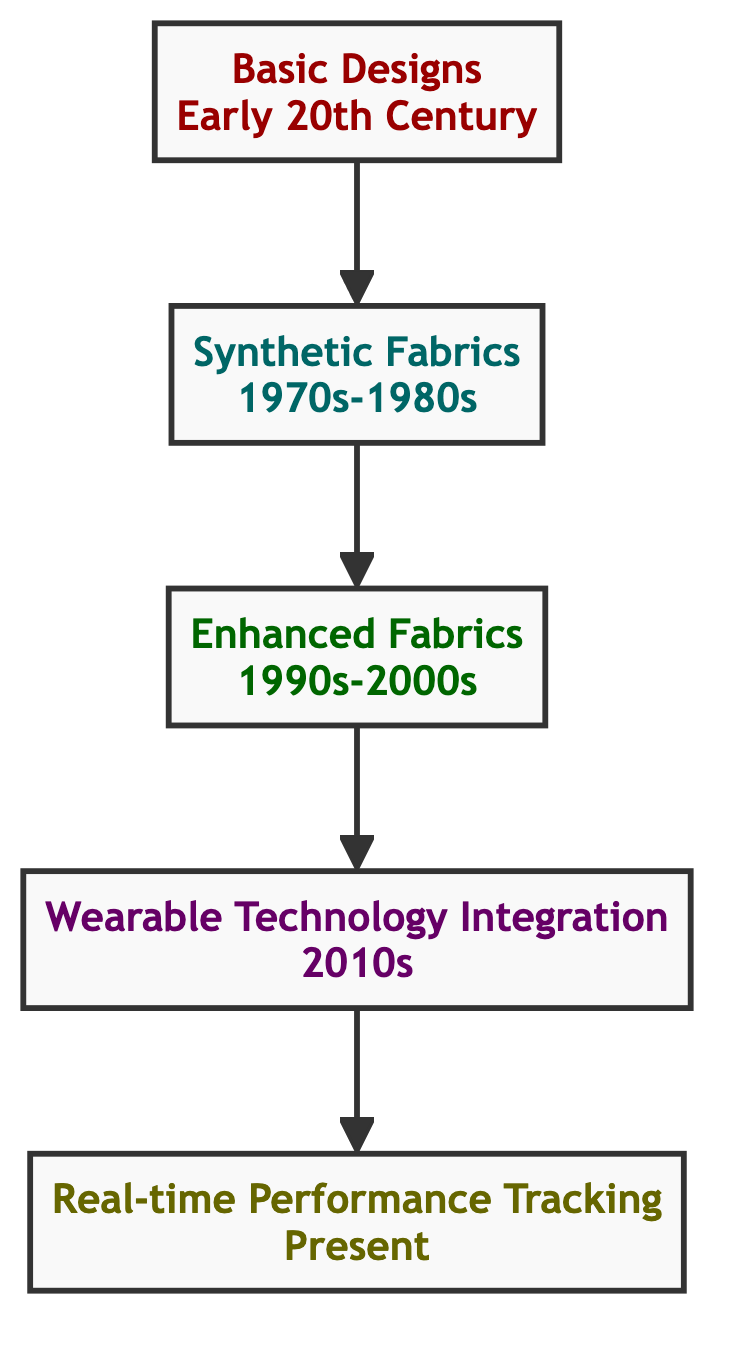What is the earliest innovation in sports apparel shown in the diagram? The diagram indicates "Basic Designs" as the first node, which corresponds to early 20th century developments in sports apparel. This is represented at the bottom of the flow chart.
Answer: Basic Designs Which innovation follows "Synthetic Fabrics" in the diagram? The flow chart displays "Enhanced Fabrics" as the direct successor to "Synthetic Fabrics," indicating a progression in apparel technology. This follows logically from one node to the next in the upward direction.
Answer: Enhanced Fabrics How many total innovations are tracked in the diagram? By counting the distinct nodes present in the flow chart, we identify five innovations: Basic Designs, Synthetic Fabrics, Enhanced Fabrics, Wearable Technology Integration, and Real-time Performance Tracking.
Answer: Five Which decade marks the introduction of "Wearable Technology Integration"? The "Wearable Technology Integration" node is associated with the 2010s. This information is explicitly stated next to the node in the diagram, placing it within the specified decade.
Answer: 2010s What is the relationship between "Enhanced Fabrics" and "Real-time Performance Tracking"? "Enhanced Fabrics" serves as a preceding technology that leads to "Wearable Technology Integration," which subsequently leads to "Real-time Performance Tracking." This shows a clear developmental pathway from one innovation to the next, indicating how improvements build upon previous advancements.
Answer: Sequential What type of materials are introduced in the "Synthetic Fabrics" phase? "Synthetic Fabrics" highlights the introduction of polyester and nylon, marking an important shift from natural fibers to synthetic materials during the 1970s-1980s. This is key within that innovation phase and gives insight into the technological advancements in materials used.
Answer: Polyester and nylon What color represents the "Real-time Performance Tracking" phase in the diagram? The node for "Real-time Performance Tracking" is filled with a light yellow color (#FFFFCC). This unique color helps to visually distinguish this innovation within the flow chart.
Answer: Light yellow Which innovation utilizes smart textiles according to the diagram? The diagram specifies "Wearable Technology Integration" as the phase where sensors and smart textiles are incorporated, including products like Nike+ and Under Armour's E39 shirt. This is explicitly detailed under that node.
Answer: Wearable Technology Integration 